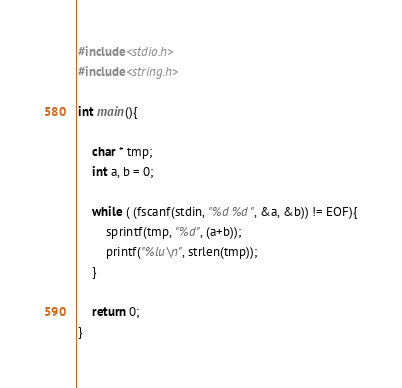<code> <loc_0><loc_0><loc_500><loc_500><_C_>#include<stdio.h>
#include<string.h>

int main(){

    char * tmp;
    int a, b = 0;

    while ( (fscanf(stdin, "%d %d", &a, &b)) != EOF){
        sprintf(tmp, "%d", (a+b));
        printf("%lu\n", strlen(tmp));
    }

    return 0;
}</code> 